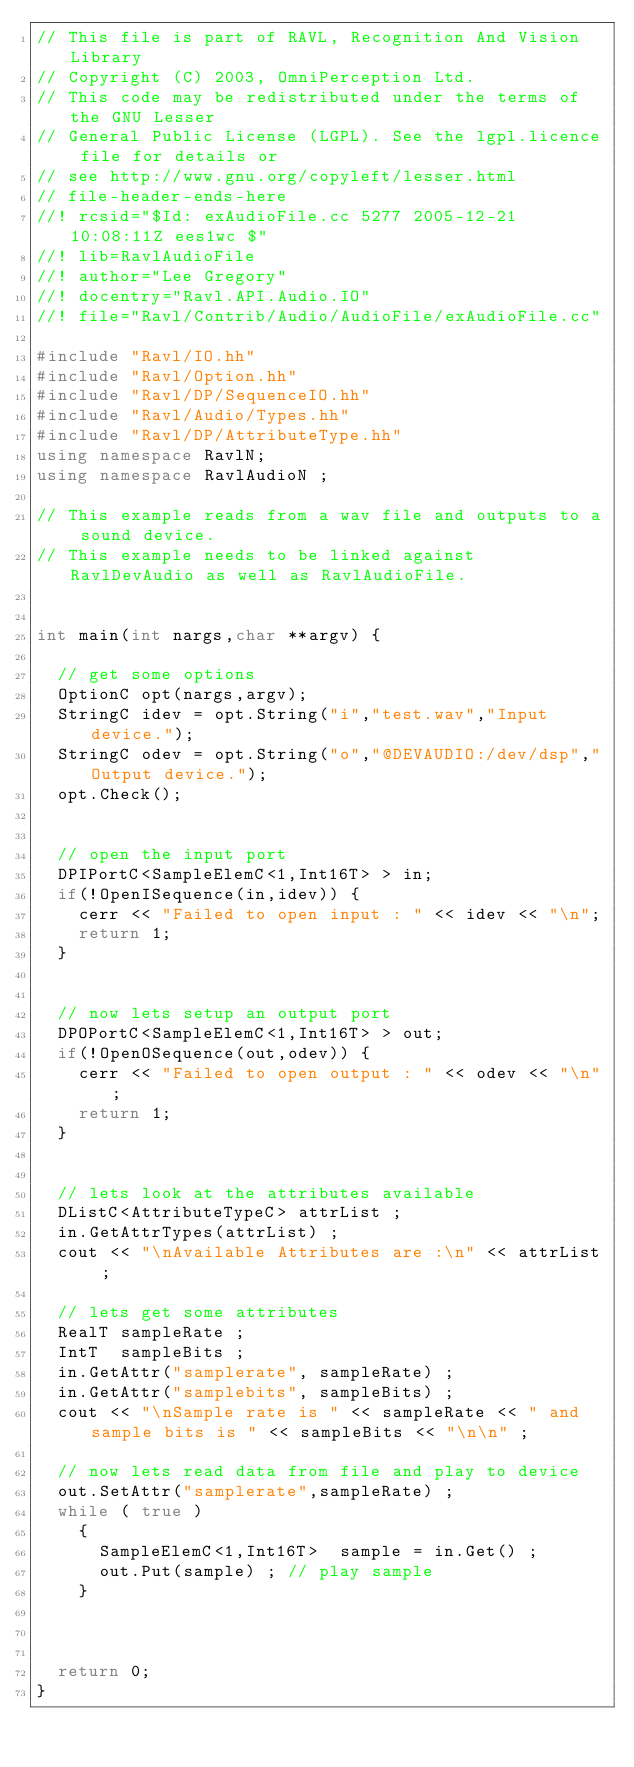<code> <loc_0><loc_0><loc_500><loc_500><_C++_>// This file is part of RAVL, Recognition And Vision Library 
// Copyright (C) 2003, OmniPerception Ltd.
// This code may be redistributed under the terms of the GNU Lesser
// General Public License (LGPL). See the lgpl.licence file for details or
// see http://www.gnu.org/copyleft/lesser.html
// file-header-ends-here
//! rcsid="$Id: exAudioFile.cc 5277 2005-12-21 10:08:11Z ees1wc $"
//! lib=RavlAudioFile
//! author="Lee Gregory"
//! docentry="Ravl.API.Audio.IO"
//! file="Ravl/Contrib/Audio/AudioFile/exAudioFile.cc"

#include "Ravl/IO.hh"
#include "Ravl/Option.hh"
#include "Ravl/DP/SequenceIO.hh"
#include "Ravl/Audio/Types.hh"
#include "Ravl/DP/AttributeType.hh"
using namespace RavlN;
using namespace RavlAudioN ; 

// This example reads from a wav file and outputs to a sound device.
// This example needs to be linked against RavlDevAudio as well as RavlAudioFile.


int main(int nargs,char **argv) {
  
  // get some options
  OptionC opt(nargs,argv);
  StringC idev = opt.String("i","test.wav","Input  device.");
  StringC odev = opt.String("o","@DEVAUDIO:/dev/dsp","Output device.");
  opt.Check();

  
  // open the input port 
  DPIPortC<SampleElemC<1,Int16T> > in;
  if(!OpenISequence(in,idev)) {
    cerr << "Failed to open input : " << idev << "\n";
    return 1;
  }
  
  
  // now lets setup an output port 
  DPOPortC<SampleElemC<1,Int16T> > out;
  if(!OpenOSequence(out,odev)) {
    cerr << "Failed to open output : " << odev << "\n";
    return 1;
  }
 
  
  // lets look at the attributes available 
  DListC<AttributeTypeC> attrList ; 
  in.GetAttrTypes(attrList) ; 
  cout << "\nAvailable Attributes are :\n" << attrList ; 
  
  // lets get some attributes 
  RealT sampleRate ; 
  IntT  sampleBits ; 
  in.GetAttr("samplerate", sampleRate) ; 
  in.GetAttr("samplebits", sampleBits) ; 
  cout << "\nSample rate is " << sampleRate << " and sample bits is " << sampleBits << "\n\n" ; 
    
  // now lets read data from file and play to device
  out.SetAttr("samplerate",sampleRate) ; 
  while ( true ) 
    {
      SampleElemC<1,Int16T>  sample = in.Get() ; 
      out.Put(sample) ; // play sample
    }


    
  return 0;
}
</code> 